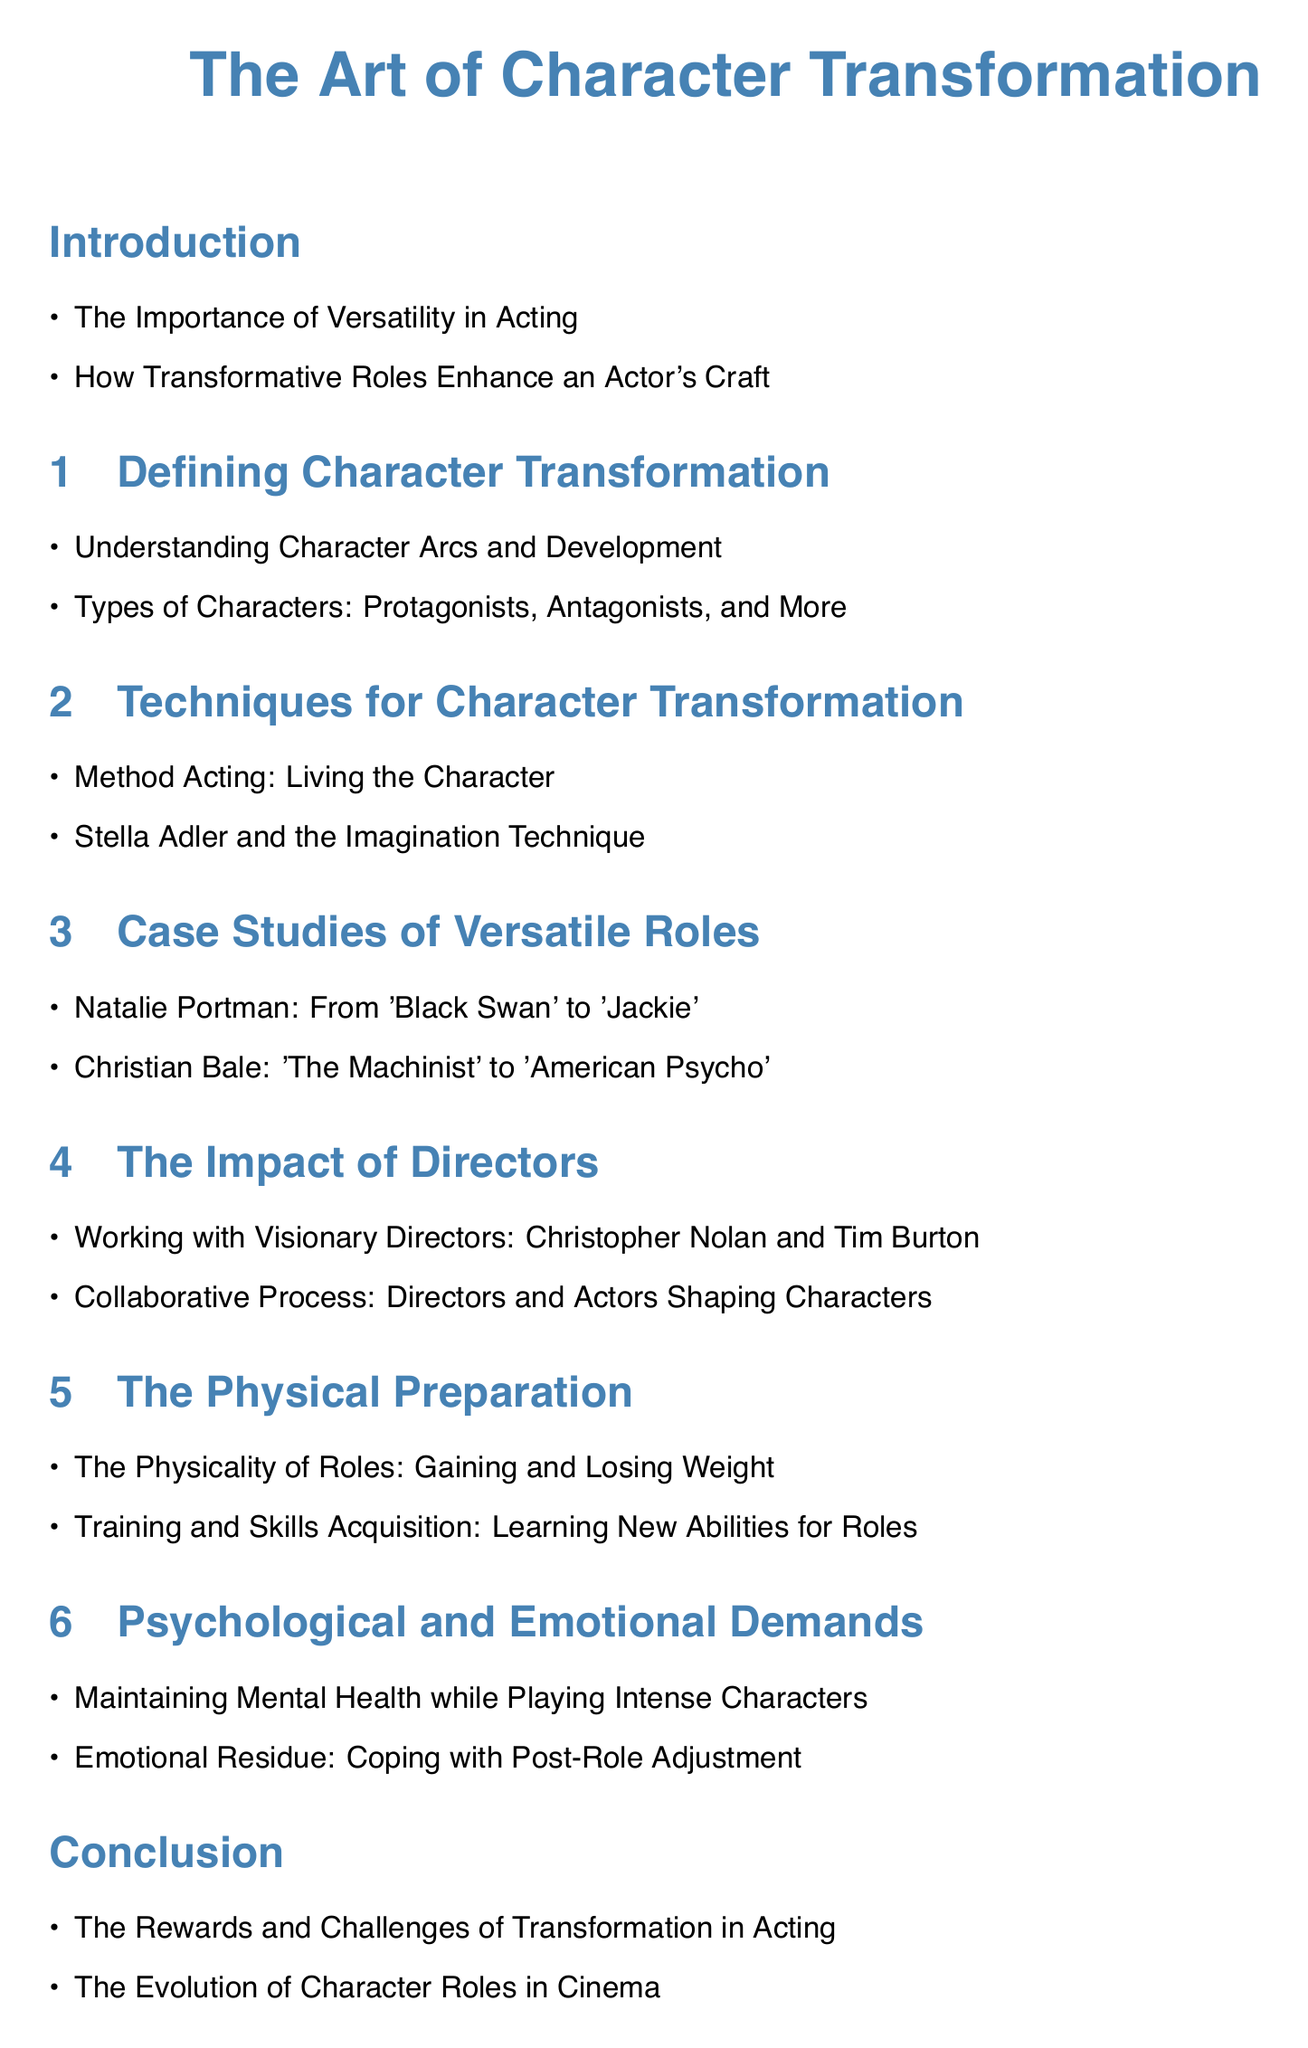What are the two main points discussed in the introduction? The introduction highlights the importance of versatility and how transformative roles enhance an actor's craft.
Answer: Versatility, Transformative roles What type of character is included in the definition section? The document lists several types of characters, including protagonists and antagonists.
Answer: Protagonists, Antagonists Which acting technique emphasizes living the character? One of the techniques for character transformation mentioned is Method Acting, which focuses on immersing oneself in the character.
Answer: Method Acting What are the two case studies highlighted for versatile roles? The document discusses Natalie Portman and Christian Bale as case studies of actors with versatile roles.
Answer: Natalie Portman, Christian Bale Who are the two directors mentioned in the impact section? The document names Christopher Nolan and Tim Burton as visionary directors whose impact on character transformation is discussed.
Answer: Christopher Nolan, Tim Burton What physical demands are discussed in this document? The physical preparation section focuses on gaining and losing weight and training for new abilities.
Answer: Gaining and losing weight, Training What is the term used for coping with post-role adjustment? The document refers to this phenomenon as "Emotional Residue."
Answer: Emotional Residue What two key aspects does the conclusion highlight? The conclusion discusses the rewards and challenges of transformation and the evolution of character roles.
Answer: Rewards and challenges, Evolution of character roles 